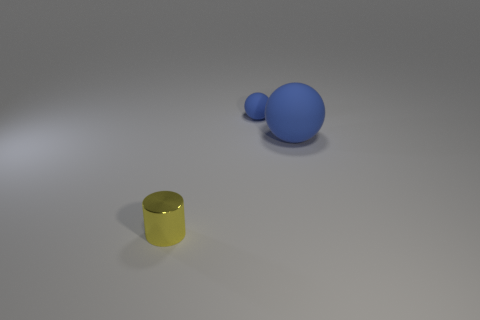Subtract all purple balls. Subtract all purple cylinders. How many balls are left? 2 Add 2 tiny gray blocks. How many objects exist? 5 Subtract all cylinders. How many objects are left? 2 Add 1 large objects. How many large objects are left? 2 Add 3 balls. How many balls exist? 5 Subtract 0 green cylinders. How many objects are left? 3 Subtract all yellow metallic cylinders. Subtract all large rubber spheres. How many objects are left? 1 